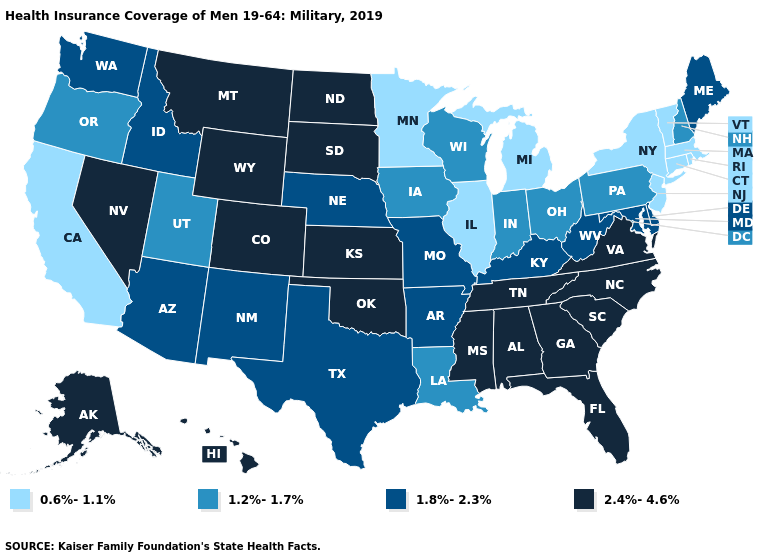What is the lowest value in the USA?
Quick response, please. 0.6%-1.1%. Does Delaware have the highest value in the South?
Write a very short answer. No. What is the lowest value in the USA?
Keep it brief. 0.6%-1.1%. Among the states that border Vermont , which have the highest value?
Give a very brief answer. New Hampshire. Name the states that have a value in the range 1.2%-1.7%?
Write a very short answer. Indiana, Iowa, Louisiana, New Hampshire, Ohio, Oregon, Pennsylvania, Utah, Wisconsin. Is the legend a continuous bar?
Keep it brief. No. How many symbols are there in the legend?
Give a very brief answer. 4. Does Texas have the same value as West Virginia?
Give a very brief answer. Yes. Does West Virginia have the highest value in the USA?
Keep it brief. No. What is the value of Texas?
Quick response, please. 1.8%-2.3%. Is the legend a continuous bar?
Short answer required. No. Name the states that have a value in the range 1.2%-1.7%?
Quick response, please. Indiana, Iowa, Louisiana, New Hampshire, Ohio, Oregon, Pennsylvania, Utah, Wisconsin. What is the value of Oklahoma?
Write a very short answer. 2.4%-4.6%. Among the states that border California , does Arizona have the highest value?
Give a very brief answer. No. 